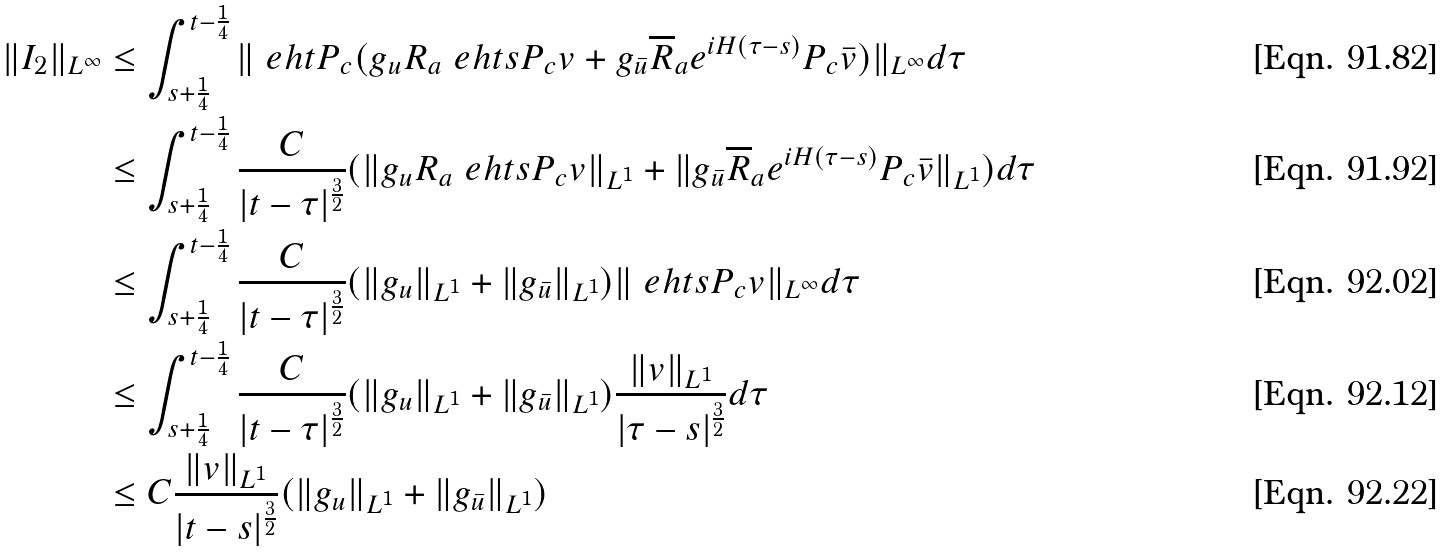<formula> <loc_0><loc_0><loc_500><loc_500>\| I _ { 2 } \| _ { L ^ { \infty } } & \leq \int _ { s + \frac { 1 } { 4 } } ^ { t - \frac { 1 } { 4 } } \| \ e h t P _ { c } ( g _ { u } R _ { a } \ e h t s P _ { c } v + g _ { \bar { u } } \overline { R } _ { a } e ^ { i H ( \tau - s ) } P _ { c } \bar { v } ) \| _ { L ^ { \infty } } d \tau \\ & \leq \int _ { s + \frac { 1 } { 4 } } ^ { t - \frac { 1 } { 4 } } \frac { C } { | t - \tau | ^ { \frac { 3 } { 2 } } } ( \| g _ { u } R _ { a } \ e h t s P _ { c } v \| _ { L ^ { 1 } } + \| g _ { \bar { u } } \overline { R } _ { a } e ^ { i H ( \tau - s ) } P _ { c } \bar { v } \| _ { L ^ { 1 } } ) d \tau \\ & \leq \int _ { s + \frac { 1 } { 4 } } ^ { t - \frac { 1 } { 4 } } \frac { C } { | t - \tau | ^ { \frac { 3 } { 2 } } } ( \| g _ { u } \| _ { L ^ { 1 } } + \| g _ { \bar { u } } \| _ { L ^ { 1 } } ) \| \ e h t s P _ { c } v \| _ { L ^ { \infty } } d \tau \\ & \leq \int _ { s + \frac { 1 } { 4 } } ^ { t - \frac { 1 } { 4 } } \frac { C } { | t - \tau | ^ { \frac { 3 } { 2 } } } ( \| g _ { u } \| _ { L ^ { 1 } } + \| g _ { \bar { u } } \| _ { L ^ { 1 } } ) \frac { \| v \| _ { L ^ { 1 } } } { | \tau - s | ^ { \frac { 3 } { 2 } } } d \tau \\ & \leq C \frac { \| v \| _ { L ^ { 1 } } } { | t - s | ^ { \frac { 3 } { 2 } } } ( \| g _ { u } \| _ { L ^ { 1 } } + \| g _ { \bar { u } } \| _ { L ^ { 1 } } )</formula> 